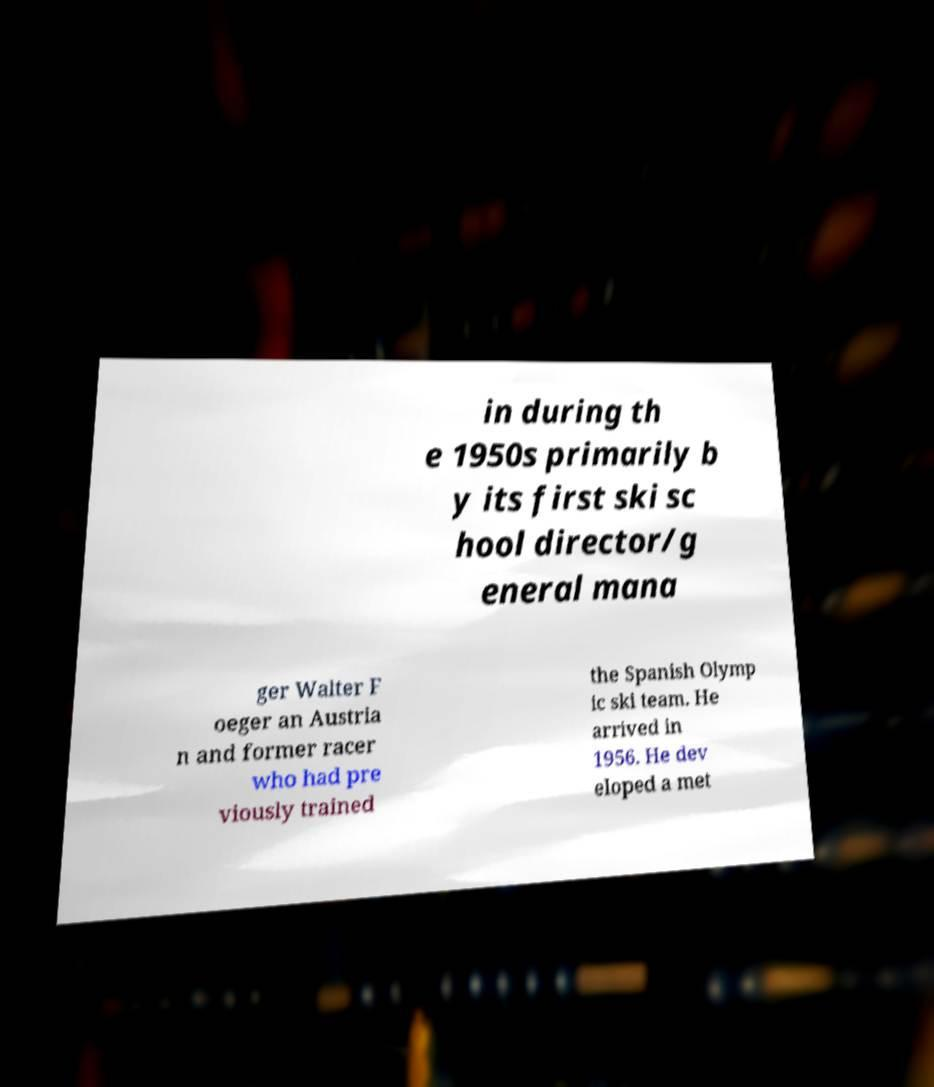What messages or text are displayed in this image? I need them in a readable, typed format. in during th e 1950s primarily b y its first ski sc hool director/g eneral mana ger Walter F oeger an Austria n and former racer who had pre viously trained the Spanish Olymp ic ski team. He arrived in 1956. He dev eloped a met 